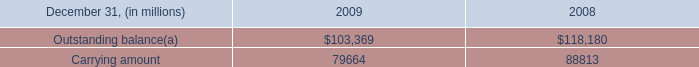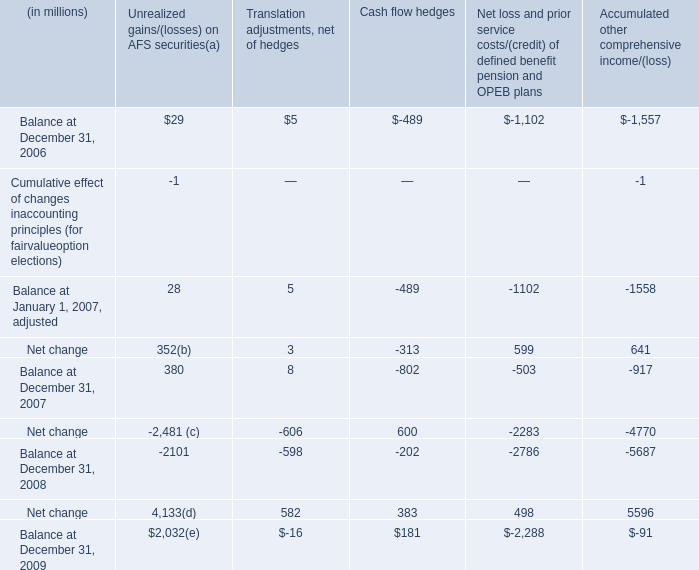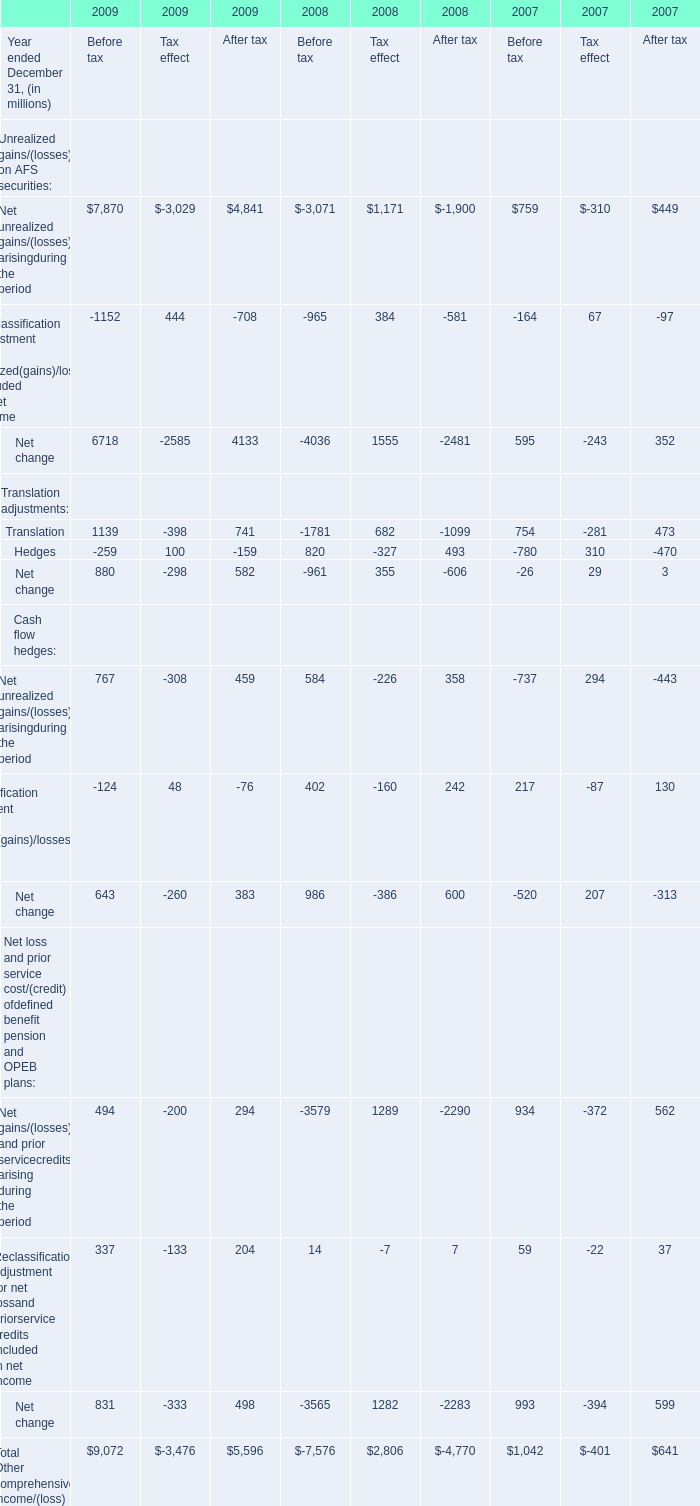What will Net unrealized gains/(losses) arisingduring the period for Before tax be like in 2010 if it develops with the same increasing rate as current? (in million) 
Computations: (767 * (1 + ((767 - 584) / 584)))
Answer: 1007.34418. 